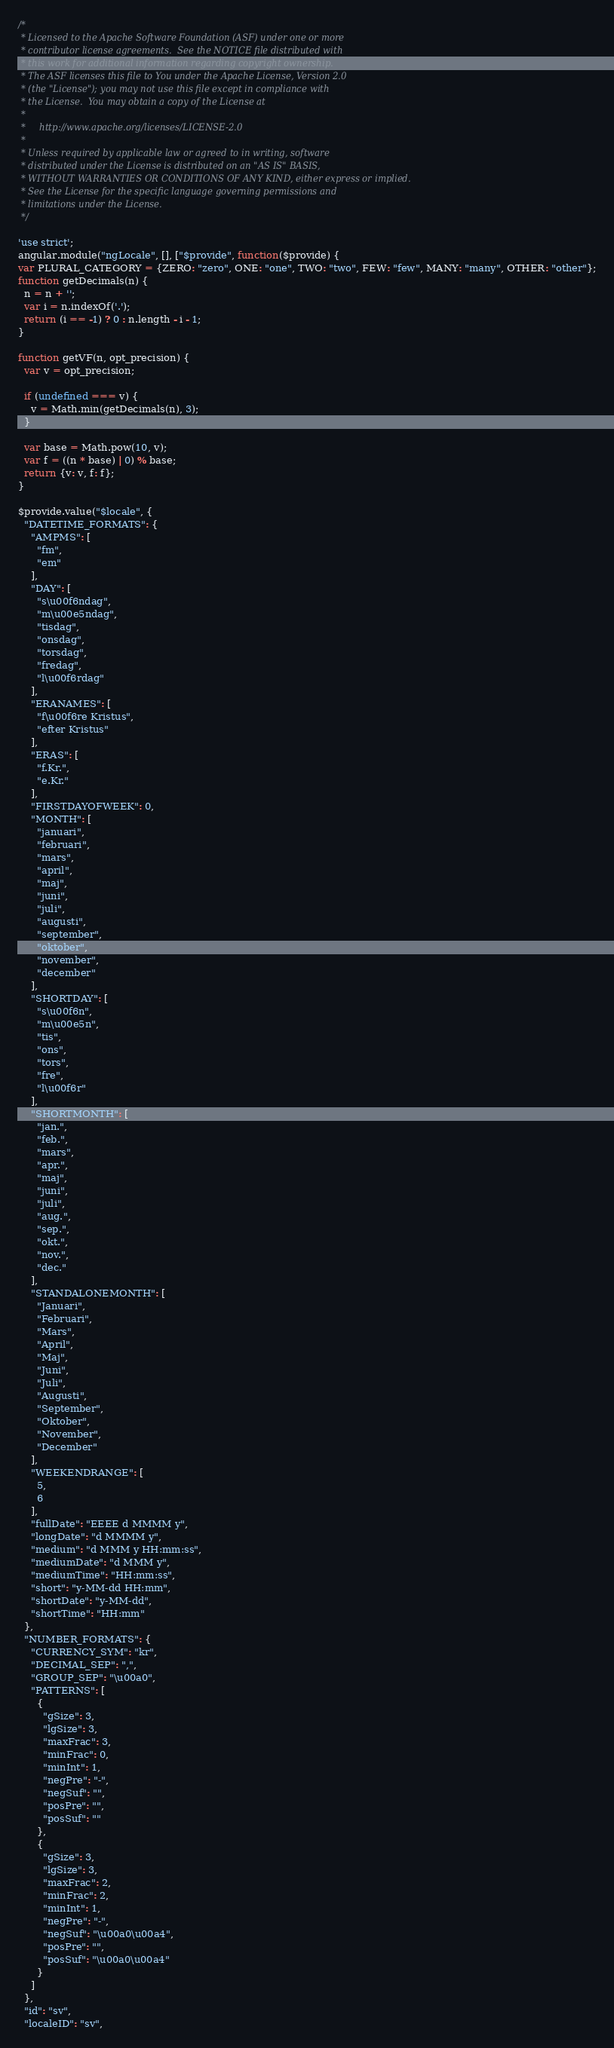Convert code to text. <code><loc_0><loc_0><loc_500><loc_500><_JavaScript_>/*
 * Licensed to the Apache Software Foundation (ASF) under one or more
 * contributor license agreements.  See the NOTICE file distributed with
 * this work for additional information regarding copyright ownership.
 * The ASF licenses this file to You under the Apache License, Version 2.0
 * (the "License"); you may not use this file except in compliance with
 * the License.  You may obtain a copy of the License at
 *
 *     http://www.apache.org/licenses/LICENSE-2.0
 *
 * Unless required by applicable law or agreed to in writing, software
 * distributed under the License is distributed on an "AS IS" BASIS,
 * WITHOUT WARRANTIES OR CONDITIONS OF ANY KIND, either express or implied.
 * See the License for the specific language governing permissions and
 * limitations under the License.
 */

'use strict';
angular.module("ngLocale", [], ["$provide", function($provide) {
var PLURAL_CATEGORY = {ZERO: "zero", ONE: "one", TWO: "two", FEW: "few", MANY: "many", OTHER: "other"};
function getDecimals(n) {
  n = n + '';
  var i = n.indexOf('.');
  return (i == -1) ? 0 : n.length - i - 1;
}

function getVF(n, opt_precision) {
  var v = opt_precision;

  if (undefined === v) {
    v = Math.min(getDecimals(n), 3);
  }

  var base = Math.pow(10, v);
  var f = ((n * base) | 0) % base;
  return {v: v, f: f};
}

$provide.value("$locale", {
  "DATETIME_FORMATS": {
    "AMPMS": [
      "fm",
      "em"
    ],
    "DAY": [
      "s\u00f6ndag",
      "m\u00e5ndag",
      "tisdag",
      "onsdag",
      "torsdag",
      "fredag",
      "l\u00f6rdag"
    ],
    "ERANAMES": [
      "f\u00f6re Kristus",
      "efter Kristus"
    ],
    "ERAS": [
      "f.Kr.",
      "e.Kr."
    ],
    "FIRSTDAYOFWEEK": 0,
    "MONTH": [
      "januari",
      "februari",
      "mars",
      "april",
      "maj",
      "juni",
      "juli",
      "augusti",
      "september",
      "oktober",
      "november",
      "december"
    ],
    "SHORTDAY": [
      "s\u00f6n",
      "m\u00e5n",
      "tis",
      "ons",
      "tors",
      "fre",
      "l\u00f6r"
    ],
    "SHORTMONTH": [
      "jan.",
      "feb.",
      "mars",
      "apr.",
      "maj",
      "juni",
      "juli",
      "aug.",
      "sep.",
      "okt.",
      "nov.",
      "dec."
    ],
    "STANDALONEMONTH": [
      "Januari",
      "Februari",
      "Mars",
      "April",
      "Maj",
      "Juni",
      "Juli",
      "Augusti",
      "September",
      "Oktober",
      "November",
      "December"
    ],
    "WEEKENDRANGE": [
      5,
      6
    ],
    "fullDate": "EEEE d MMMM y",
    "longDate": "d MMMM y",
    "medium": "d MMM y HH:mm:ss",
    "mediumDate": "d MMM y",
    "mediumTime": "HH:mm:ss",
    "short": "y-MM-dd HH:mm",
    "shortDate": "y-MM-dd",
    "shortTime": "HH:mm"
  },
  "NUMBER_FORMATS": {
    "CURRENCY_SYM": "kr",
    "DECIMAL_SEP": ",",
    "GROUP_SEP": "\u00a0",
    "PATTERNS": [
      {
        "gSize": 3,
        "lgSize": 3,
        "maxFrac": 3,
        "minFrac": 0,
        "minInt": 1,
        "negPre": "-",
        "negSuf": "",
        "posPre": "",
        "posSuf": ""
      },
      {
        "gSize": 3,
        "lgSize": 3,
        "maxFrac": 2,
        "minFrac": 2,
        "minInt": 1,
        "negPre": "-",
        "negSuf": "\u00a0\u00a4",
        "posPre": "",
        "posSuf": "\u00a0\u00a4"
      }
    ]
  },
  "id": "sv",
  "localeID": "sv",</code> 